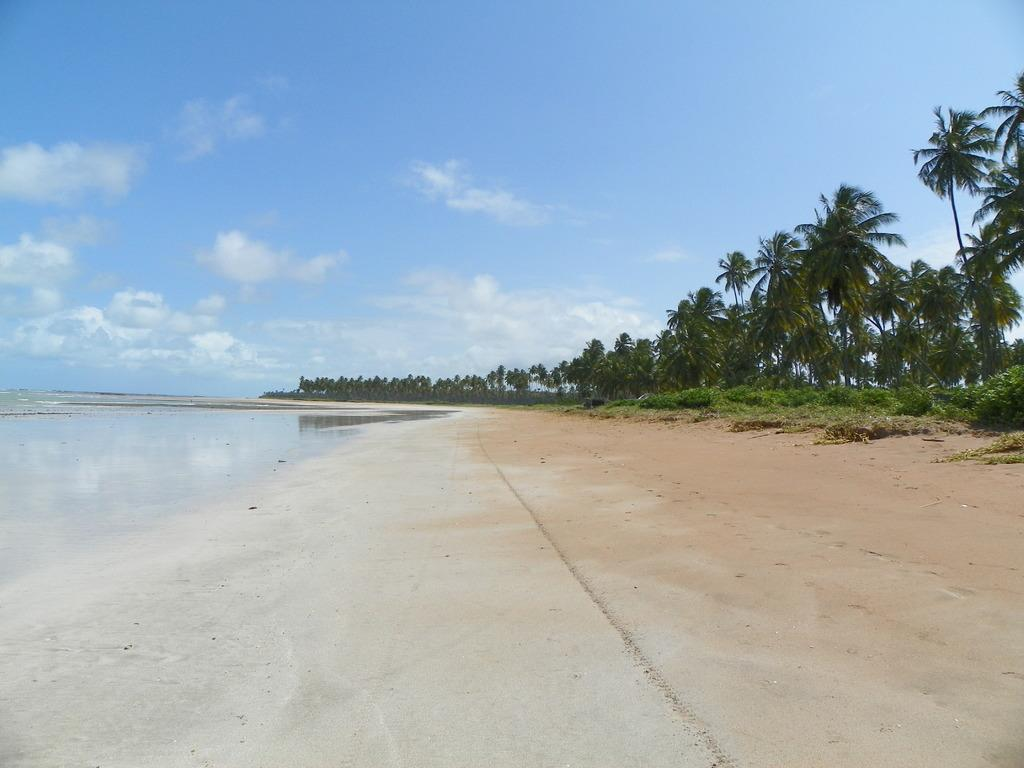What type of location is shown in the image? The image depicts a beach. What can be seen on the left side of the image? There is water on the left side of the image. What type of vegetation is on the right side of the image? There are trees on the right side of the image. What is visible at the top of the image? The sky is visible at the top of the image. What can be observed in the sky? Clouds are present in the sky. What type of fowl can be seen nesting in the wood on the beach? There is no fowl or wood present in the image; it depicts a beach with water, trees, and a sky with clouds. 